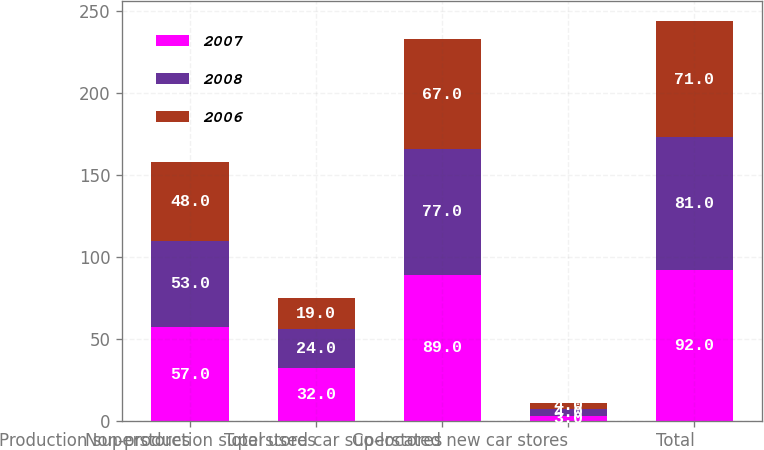<chart> <loc_0><loc_0><loc_500><loc_500><stacked_bar_chart><ecel><fcel>Production superstores<fcel>Non-production superstores<fcel>Total used car superstores<fcel>Co-located new car stores<fcel>Total<nl><fcel>2007<fcel>57<fcel>32<fcel>89<fcel>3<fcel>92<nl><fcel>2008<fcel>53<fcel>24<fcel>77<fcel>4<fcel>81<nl><fcel>2006<fcel>48<fcel>19<fcel>67<fcel>4<fcel>71<nl></chart> 